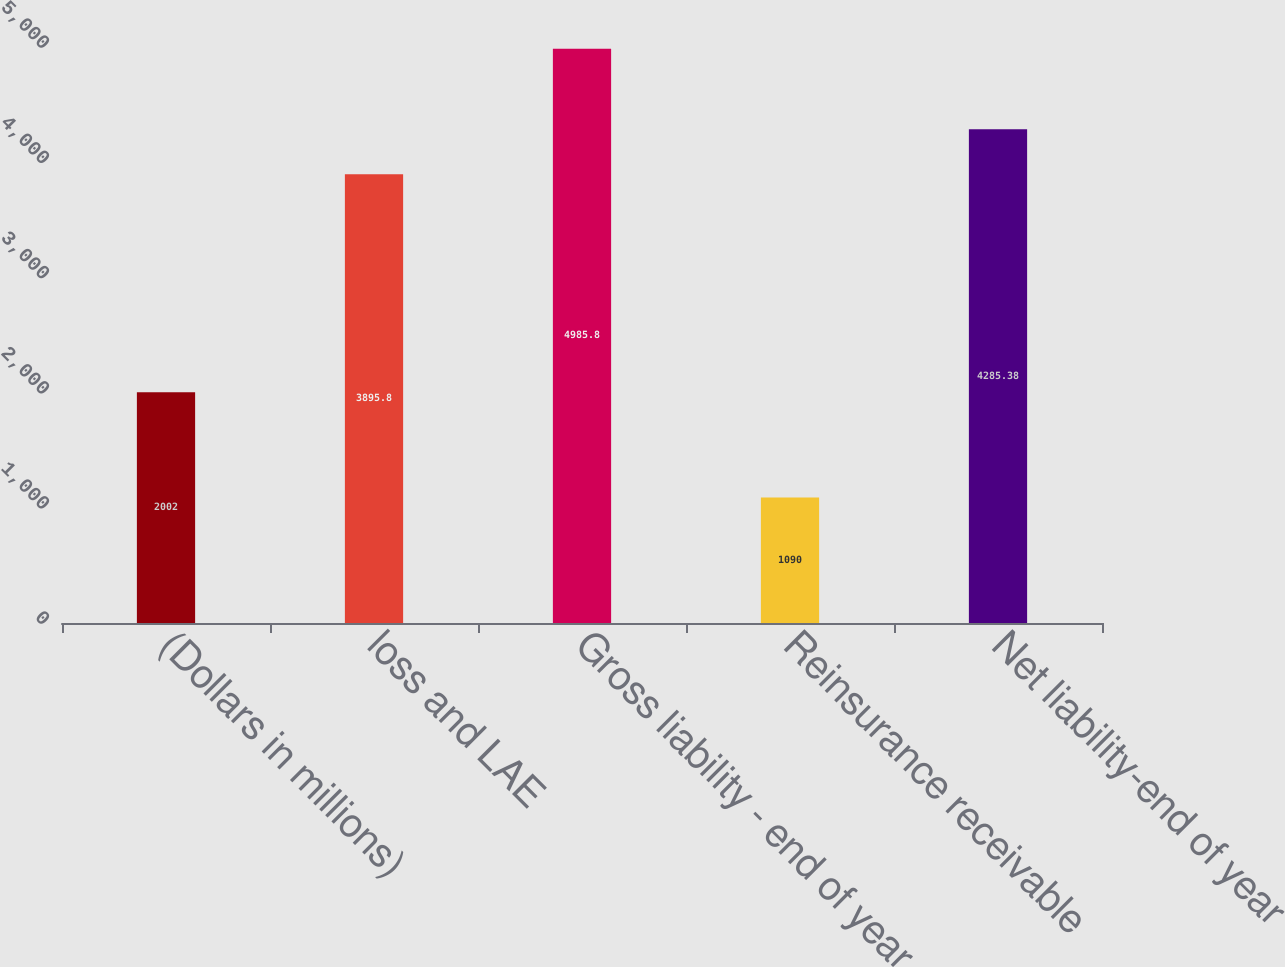<chart> <loc_0><loc_0><loc_500><loc_500><bar_chart><fcel>(Dollars in millions)<fcel>loss and LAE<fcel>Gross liability - end of year<fcel>Reinsurance receivable<fcel>Net liability-end of year<nl><fcel>2002<fcel>3895.8<fcel>4985.8<fcel>1090<fcel>4285.38<nl></chart> 